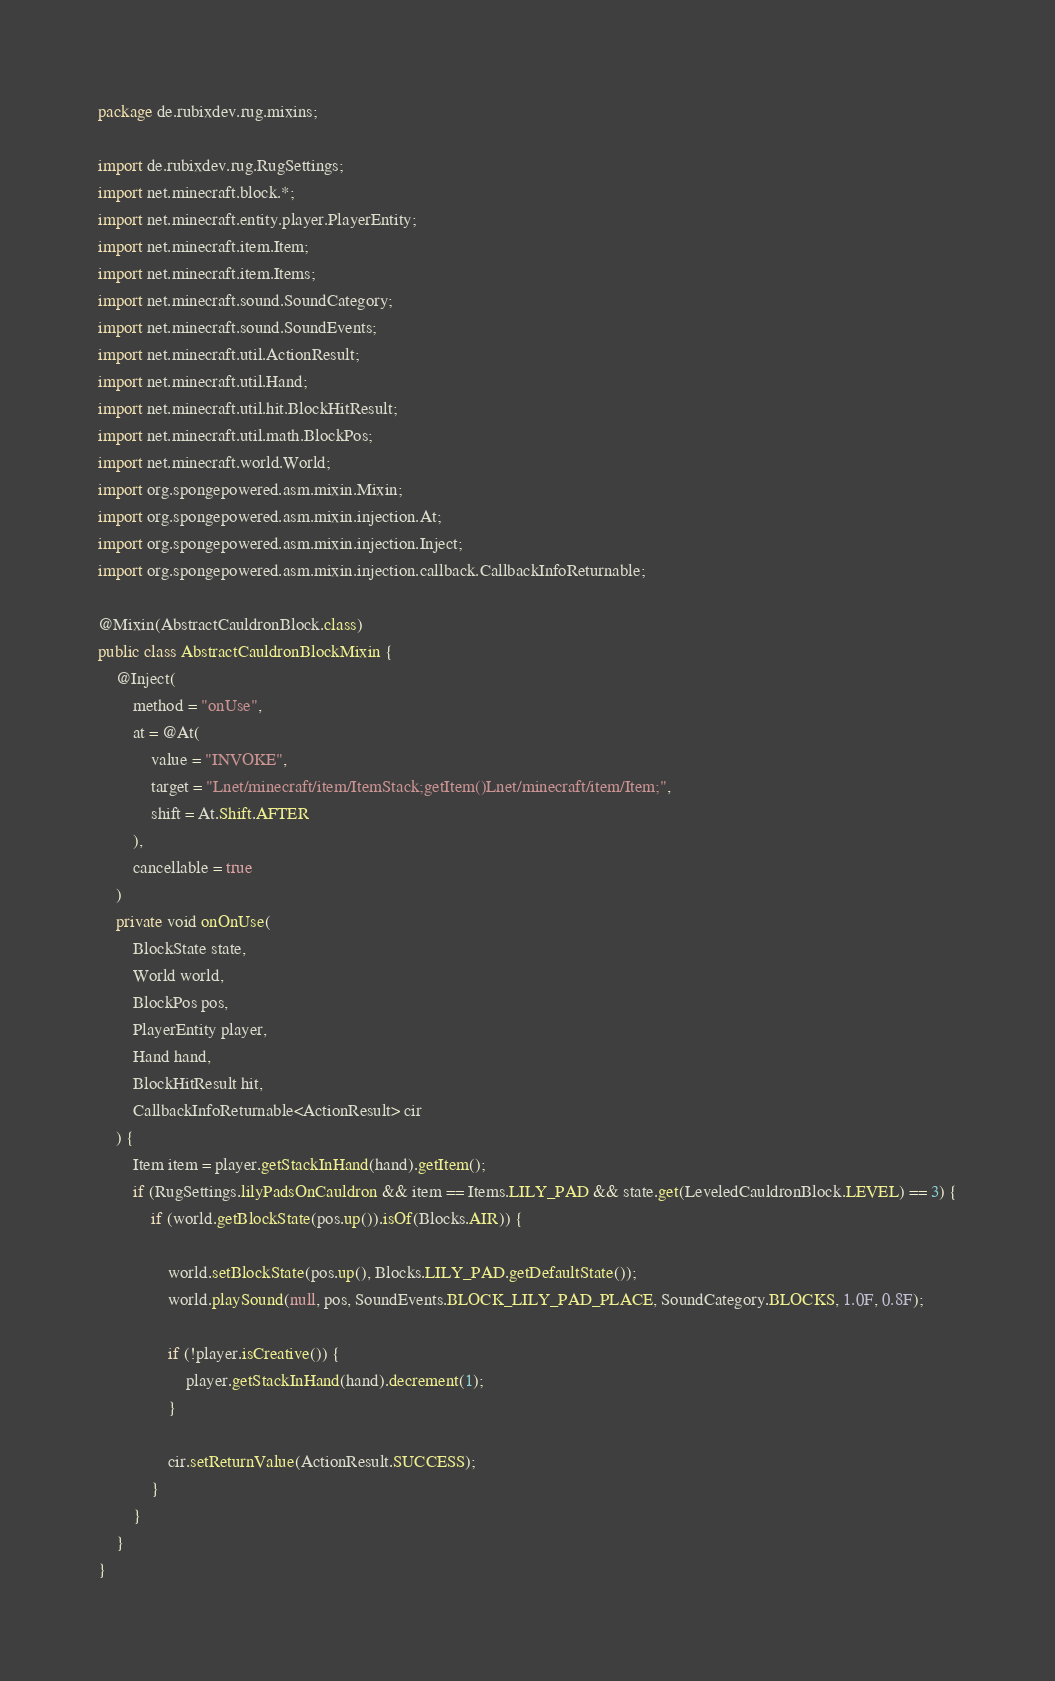<code> <loc_0><loc_0><loc_500><loc_500><_Java_>package de.rubixdev.rug.mixins;

import de.rubixdev.rug.RugSettings;
import net.minecraft.block.*;
import net.minecraft.entity.player.PlayerEntity;
import net.minecraft.item.Item;
import net.minecraft.item.Items;
import net.minecraft.sound.SoundCategory;
import net.minecraft.sound.SoundEvents;
import net.minecraft.util.ActionResult;
import net.minecraft.util.Hand;
import net.minecraft.util.hit.BlockHitResult;
import net.minecraft.util.math.BlockPos;
import net.minecraft.world.World;
import org.spongepowered.asm.mixin.Mixin;
import org.spongepowered.asm.mixin.injection.At;
import org.spongepowered.asm.mixin.injection.Inject;
import org.spongepowered.asm.mixin.injection.callback.CallbackInfoReturnable;

@Mixin(AbstractCauldronBlock.class)
public class AbstractCauldronBlockMixin {
    @Inject(
        method = "onUse",
        at = @At(
            value = "INVOKE",
            target = "Lnet/minecraft/item/ItemStack;getItem()Lnet/minecraft/item/Item;",
            shift = At.Shift.AFTER
        ),
        cancellable = true
    )
    private void onOnUse(
        BlockState state,
        World world,
        BlockPos pos,
        PlayerEntity player,
        Hand hand,
        BlockHitResult hit,
        CallbackInfoReturnable<ActionResult> cir
    ) {
        Item item = player.getStackInHand(hand).getItem();
        if (RugSettings.lilyPadsOnCauldron && item == Items.LILY_PAD && state.get(LeveledCauldronBlock.LEVEL) == 3) {
            if (world.getBlockState(pos.up()).isOf(Blocks.AIR)) {

                world.setBlockState(pos.up(), Blocks.LILY_PAD.getDefaultState());
                world.playSound(null, pos, SoundEvents.BLOCK_LILY_PAD_PLACE, SoundCategory.BLOCKS, 1.0F, 0.8F);

                if (!player.isCreative()) {
                    player.getStackInHand(hand).decrement(1);
                }

                cir.setReturnValue(ActionResult.SUCCESS);
            }
        }
    }
}
</code> 